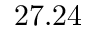Convert formula to latex. <formula><loc_0><loc_0><loc_500><loc_500>2 7 . 2 4</formula> 